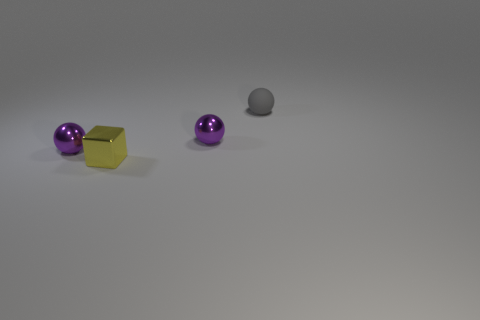What shape is the tiny purple thing left of the yellow metal object?
Offer a very short reply. Sphere. Is the color of the rubber sphere that is behind the block the same as the shiny block?
Your answer should be compact. No. Is the size of the gray rubber object behind the cube the same as the yellow shiny cube?
Your answer should be compact. Yes. Are there any large matte cylinders that have the same color as the rubber sphere?
Make the answer very short. No. Are there any yellow shiny things to the right of the small purple metal object on the right side of the tiny block?
Give a very brief answer. No. Is there a purple sphere that has the same material as the tiny gray object?
Give a very brief answer. No. The tiny purple thing behind the purple ball that is on the left side of the tiny yellow cube is made of what material?
Your response must be concise. Metal. What is the tiny sphere that is both in front of the tiny matte sphere and on the right side of the cube made of?
Keep it short and to the point. Metal. Are there an equal number of tiny gray things behind the small matte sphere and cyan metallic cylinders?
Keep it short and to the point. Yes. How many shiny things have the same shape as the small gray matte object?
Provide a short and direct response. 2. 